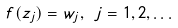Convert formula to latex. <formula><loc_0><loc_0><loc_500><loc_500>f ( z _ { j } ) = w _ { j } , \ j = 1 , 2 , \dots</formula> 